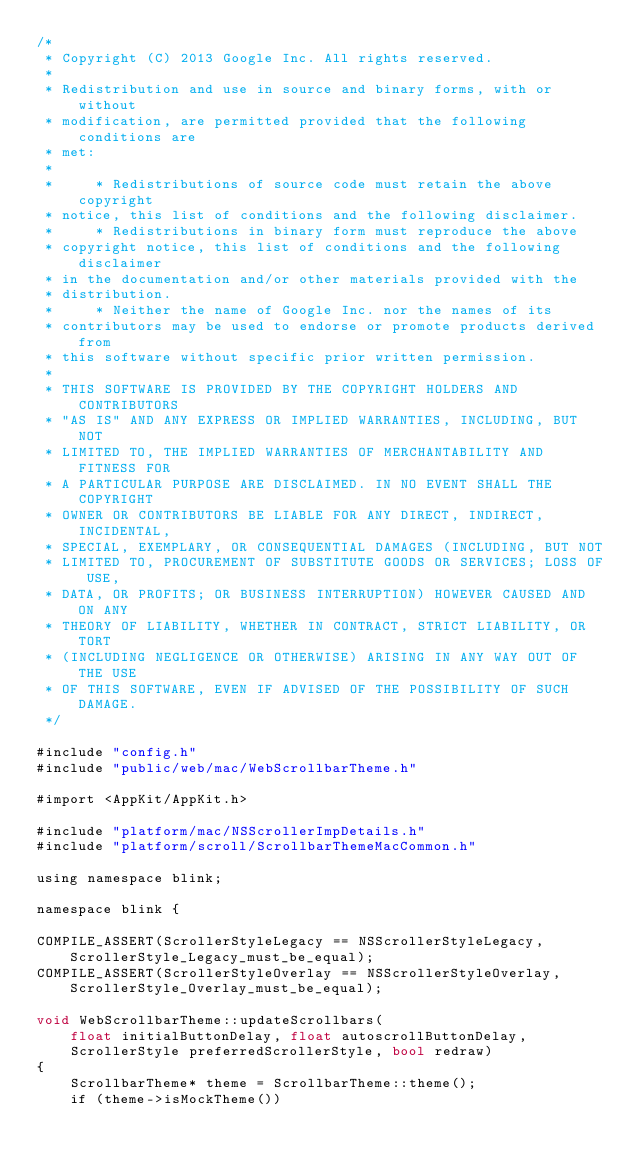Convert code to text. <code><loc_0><loc_0><loc_500><loc_500><_ObjectiveC_>/*
 * Copyright (C) 2013 Google Inc. All rights reserved.
 *
 * Redistribution and use in source and binary forms, with or without
 * modification, are permitted provided that the following conditions are
 * met:
 *
 *     * Redistributions of source code must retain the above copyright
 * notice, this list of conditions and the following disclaimer.
 *     * Redistributions in binary form must reproduce the above
 * copyright notice, this list of conditions and the following disclaimer
 * in the documentation and/or other materials provided with the
 * distribution.
 *     * Neither the name of Google Inc. nor the names of its
 * contributors may be used to endorse or promote products derived from
 * this software without specific prior written permission.
 *
 * THIS SOFTWARE IS PROVIDED BY THE COPYRIGHT HOLDERS AND CONTRIBUTORS
 * "AS IS" AND ANY EXPRESS OR IMPLIED WARRANTIES, INCLUDING, BUT NOT
 * LIMITED TO, THE IMPLIED WARRANTIES OF MERCHANTABILITY AND FITNESS FOR
 * A PARTICULAR PURPOSE ARE DISCLAIMED. IN NO EVENT SHALL THE COPYRIGHT
 * OWNER OR CONTRIBUTORS BE LIABLE FOR ANY DIRECT, INDIRECT, INCIDENTAL,
 * SPECIAL, EXEMPLARY, OR CONSEQUENTIAL DAMAGES (INCLUDING, BUT NOT
 * LIMITED TO, PROCUREMENT OF SUBSTITUTE GOODS OR SERVICES; LOSS OF USE,
 * DATA, OR PROFITS; OR BUSINESS INTERRUPTION) HOWEVER CAUSED AND ON ANY
 * THEORY OF LIABILITY, WHETHER IN CONTRACT, STRICT LIABILITY, OR TORT
 * (INCLUDING NEGLIGENCE OR OTHERWISE) ARISING IN ANY WAY OUT OF THE USE
 * OF THIS SOFTWARE, EVEN IF ADVISED OF THE POSSIBILITY OF SUCH DAMAGE.
 */

#include "config.h"
#include "public/web/mac/WebScrollbarTheme.h"

#import <AppKit/AppKit.h>

#include "platform/mac/NSScrollerImpDetails.h"
#include "platform/scroll/ScrollbarThemeMacCommon.h"

using namespace blink;

namespace blink {

COMPILE_ASSERT(ScrollerStyleLegacy == NSScrollerStyleLegacy, ScrollerStyle_Legacy_must_be_equal);
COMPILE_ASSERT(ScrollerStyleOverlay == NSScrollerStyleOverlay, ScrollerStyle_Overlay_must_be_equal);

void WebScrollbarTheme::updateScrollbars(
    float initialButtonDelay, float autoscrollButtonDelay,
    ScrollerStyle preferredScrollerStyle, bool redraw)
{
    ScrollbarTheme* theme = ScrollbarTheme::theme();
    if (theme->isMockTheme())</code> 